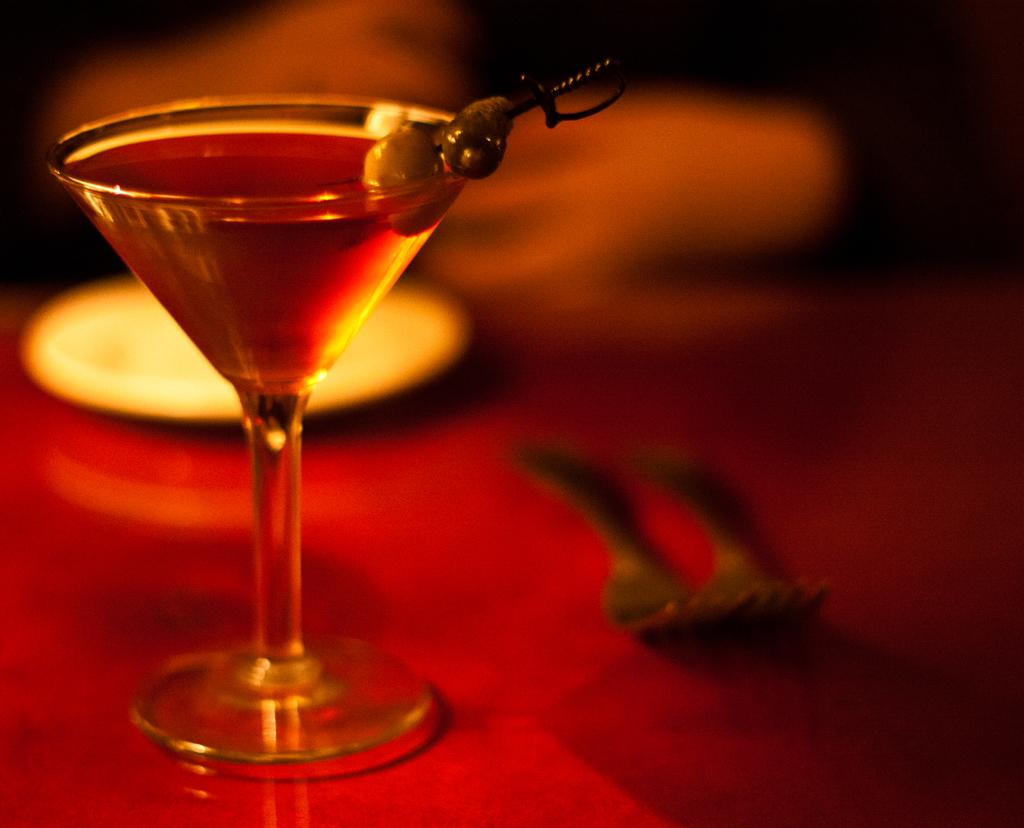What is in the glass that is visible in the image? There is a glass of juice in the image. What is added to the top of the glass? There are fruits at the top of the glass. What utensils can be seen in the background of the image? There are forks in the background of the image. What is present in the background of the image that might be used for serving food? There is a plate in the background of the image. What type of skate is being used to divide the fruits in the image? There is no skate present in the image, and the fruits are not being divided. 